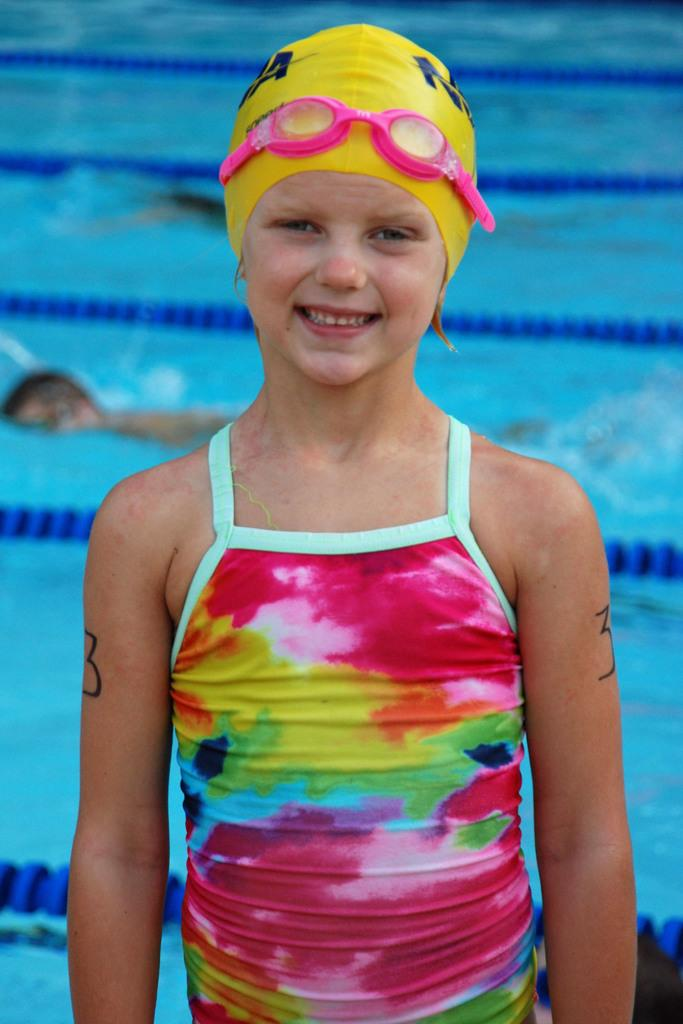What is the girl in the image doing? The girl is standing and smiling in the image. What activity is taking place in the background of the image? There are two persons swimming in the background of the image. What type of setting is visible in the background? The background of the image includes a swimming pool. What feature is present in the swimming pool to separate lanes? Swimming pool lane ropes are present in the image. What type of pump can be seen in the middle of the image? There is no pump present in the image; it features a girl standing and smiling, with a swimming pool and swimming activity in the background. 